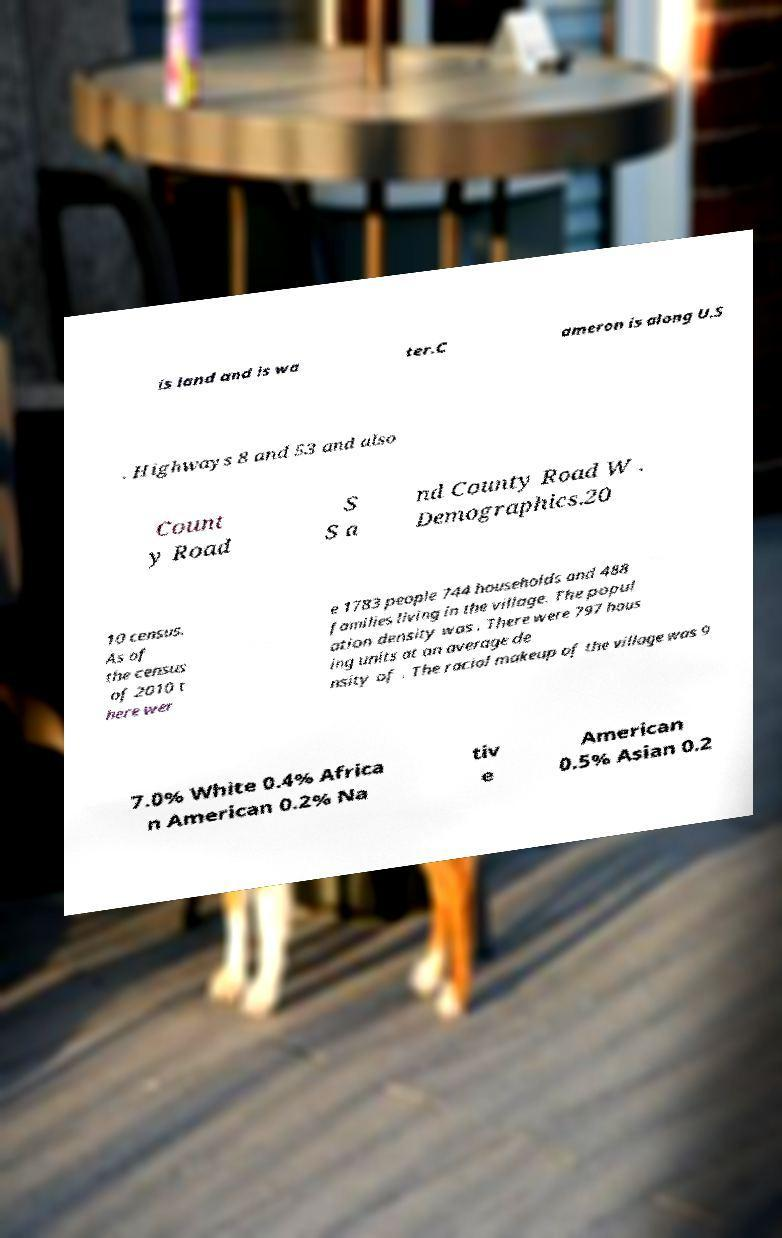Can you accurately transcribe the text from the provided image for me? is land and is wa ter.C ameron is along U.S . Highways 8 and 53 and also Count y Road S S a nd County Road W . Demographics.20 10 census. As of the census of 2010 t here wer e 1783 people 744 households and 488 families living in the village. The popul ation density was . There were 797 hous ing units at an average de nsity of . The racial makeup of the village was 9 7.0% White 0.4% Africa n American 0.2% Na tiv e American 0.5% Asian 0.2 